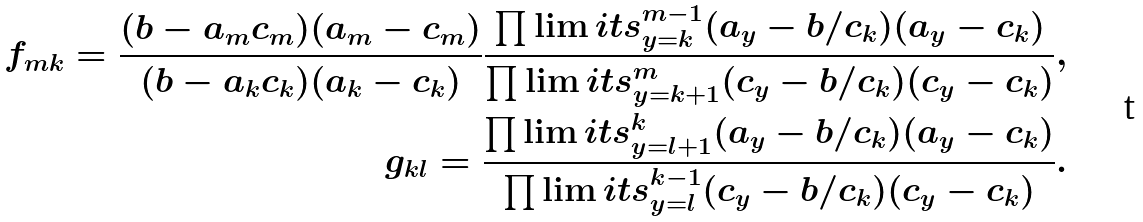<formula> <loc_0><loc_0><loc_500><loc_500>f _ { m k } = \frac { ( b - a _ { m } c _ { m } ) ( a _ { m } - c _ { m } ) } { ( b - a _ { k } c _ { k } ) ( a _ { k } - c _ { k } ) } \frac { \prod \lim i t s _ { y = k } ^ { m - 1 } ( a _ { y } - b / c _ { k } ) ( a _ { y } - c _ { k } ) } { \prod \lim i t s _ { y = k + 1 } ^ { m } ( c _ { y } - b / c _ { k } ) ( c _ { y } - c _ { k } ) } , \\ g _ { k l } = \frac { \prod \lim i t s _ { y = l + 1 } ^ { k } ( a _ { y } - b / c _ { k } ) ( a _ { y } - c _ { k } ) } { \prod \lim i t s _ { y = l } ^ { k - 1 } ( c _ { y } - b / c _ { k } ) ( c _ { y } - c _ { k } ) } .</formula> 